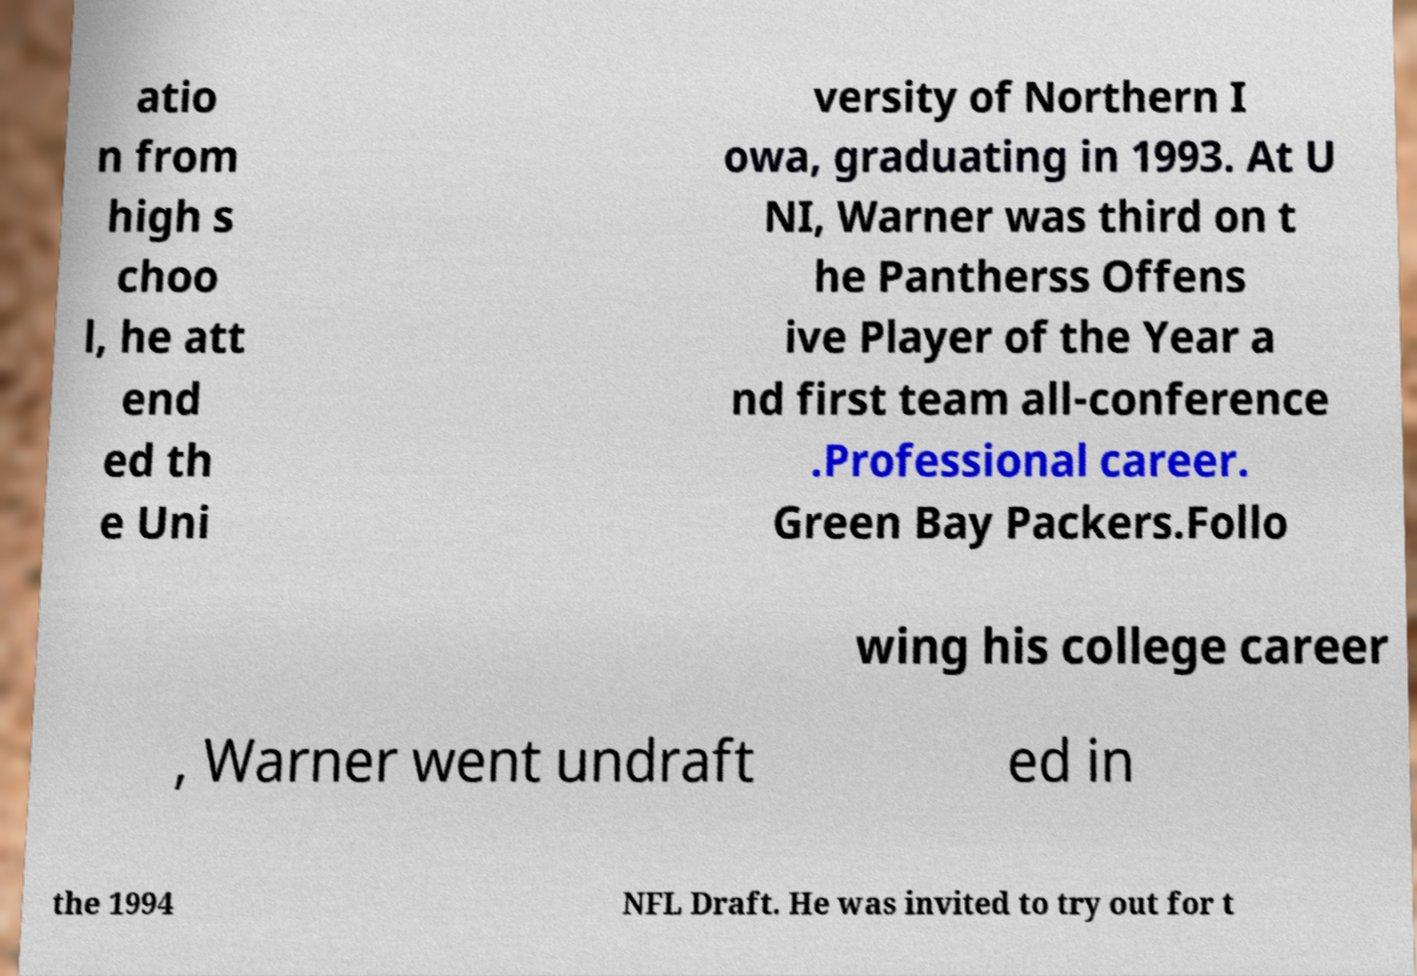Can you read and provide the text displayed in the image?This photo seems to have some interesting text. Can you extract and type it out for me? atio n from high s choo l, he att end ed th e Uni versity of Northern I owa, graduating in 1993. At U NI, Warner was third on t he Pantherss Offens ive Player of the Year a nd first team all-conference .Professional career. Green Bay Packers.Follo wing his college career , Warner went undraft ed in the 1994 NFL Draft. He was invited to try out for t 